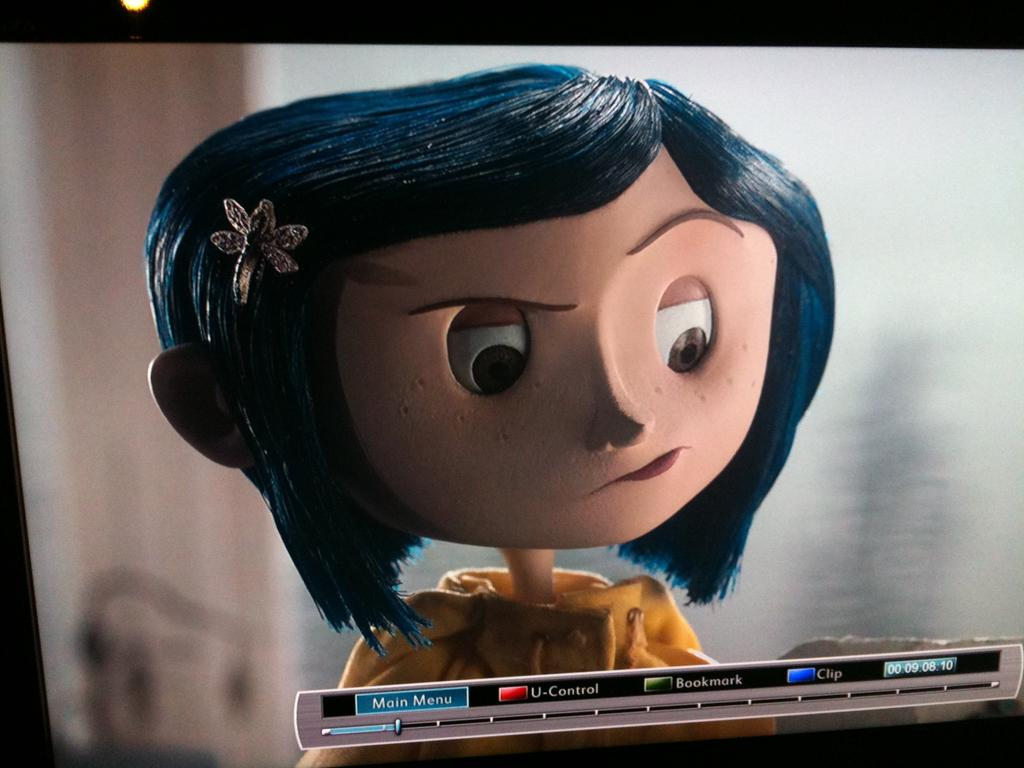What type of image is shown in the animation? The image is animated. What character can be seen in the animated image? There is a cartoon image of a girl in the image. Is there any text present in the animated image? Yes, there is text visible in the image. How many pigs are present in the animated image? There are no pigs present in the animated image; it features a cartoon girl and text. What time of day does the animated image take place in? The provided facts do not mention the time of day, so it cannot be determined from the image. 